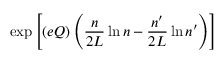<formula> <loc_0><loc_0><loc_500><loc_500>\exp \left [ ( e Q ) \left ( \frac { n } { 2 L } \ln { n } - \frac { n ^ { \prime } } { 2 L } \ln { n ^ { \prime } } \right ) \right ]</formula> 